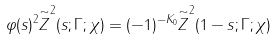<formula> <loc_0><loc_0><loc_500><loc_500>\varphi ( s ) ^ { 2 } \overset { \sim } { Z } ^ { 2 } ( s ; \Gamma ; \chi ) = ( - 1 ) ^ { - K _ { 0 } } \overset { \sim } { Z } ^ { 2 } ( 1 - s ; \Gamma ; \chi )</formula> 